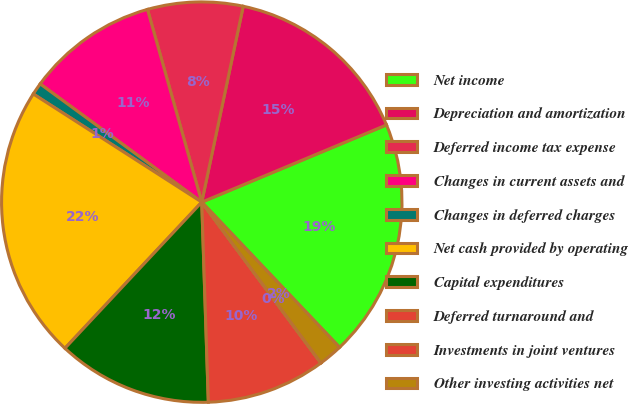Convert chart. <chart><loc_0><loc_0><loc_500><loc_500><pie_chart><fcel>Net income<fcel>Depreciation and amortization<fcel>Deferred income tax expense<fcel>Changes in current assets and<fcel>Changes in deferred charges<fcel>Net cash provided by operating<fcel>Capital expenditures<fcel>Deferred turnaround and<fcel>Investments in joint ventures<fcel>Other investing activities net<nl><fcel>19.22%<fcel>15.38%<fcel>7.69%<fcel>10.58%<fcel>0.97%<fcel>22.11%<fcel>12.5%<fcel>9.62%<fcel>0.01%<fcel>1.93%<nl></chart> 